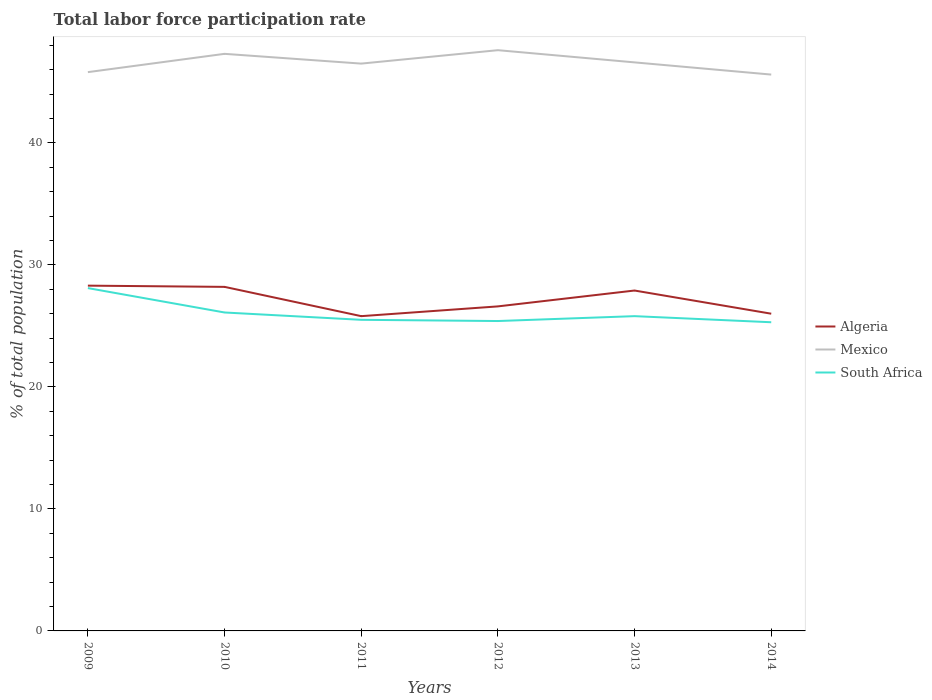Across all years, what is the maximum total labor force participation rate in Mexico?
Ensure brevity in your answer.  45.6. What is the total total labor force participation rate in Algeria in the graph?
Your answer should be very brief. 0.6. Is the total labor force participation rate in Mexico strictly greater than the total labor force participation rate in South Africa over the years?
Offer a very short reply. No. What is the difference between two consecutive major ticks on the Y-axis?
Offer a terse response. 10. Does the graph contain grids?
Your response must be concise. No. Where does the legend appear in the graph?
Offer a very short reply. Center right. How many legend labels are there?
Offer a terse response. 3. How are the legend labels stacked?
Your response must be concise. Vertical. What is the title of the graph?
Provide a succinct answer. Total labor force participation rate. What is the label or title of the Y-axis?
Your response must be concise. % of total population. What is the % of total population of Algeria in 2009?
Offer a very short reply. 28.3. What is the % of total population of Mexico in 2009?
Give a very brief answer. 45.8. What is the % of total population in South Africa in 2009?
Your answer should be compact. 28.1. What is the % of total population of Algeria in 2010?
Offer a terse response. 28.2. What is the % of total population in Mexico in 2010?
Give a very brief answer. 47.3. What is the % of total population of South Africa in 2010?
Provide a succinct answer. 26.1. What is the % of total population of Algeria in 2011?
Provide a succinct answer. 25.8. What is the % of total population of Mexico in 2011?
Keep it short and to the point. 46.5. What is the % of total population of South Africa in 2011?
Offer a terse response. 25.5. What is the % of total population of Algeria in 2012?
Make the answer very short. 26.6. What is the % of total population in Mexico in 2012?
Offer a very short reply. 47.6. What is the % of total population of South Africa in 2012?
Offer a terse response. 25.4. What is the % of total population of Algeria in 2013?
Offer a very short reply. 27.9. What is the % of total population in Mexico in 2013?
Ensure brevity in your answer.  46.6. What is the % of total population of South Africa in 2013?
Offer a terse response. 25.8. What is the % of total population in Algeria in 2014?
Offer a terse response. 26. What is the % of total population of Mexico in 2014?
Give a very brief answer. 45.6. What is the % of total population in South Africa in 2014?
Your answer should be very brief. 25.3. Across all years, what is the maximum % of total population of Algeria?
Your answer should be compact. 28.3. Across all years, what is the maximum % of total population in Mexico?
Provide a succinct answer. 47.6. Across all years, what is the maximum % of total population of South Africa?
Offer a very short reply. 28.1. Across all years, what is the minimum % of total population in Algeria?
Keep it short and to the point. 25.8. Across all years, what is the minimum % of total population of Mexico?
Your answer should be very brief. 45.6. Across all years, what is the minimum % of total population in South Africa?
Offer a terse response. 25.3. What is the total % of total population of Algeria in the graph?
Offer a very short reply. 162.8. What is the total % of total population in Mexico in the graph?
Make the answer very short. 279.4. What is the total % of total population in South Africa in the graph?
Give a very brief answer. 156.2. What is the difference between the % of total population in Algeria in 2009 and that in 2011?
Your answer should be compact. 2.5. What is the difference between the % of total population in South Africa in 2009 and that in 2011?
Offer a very short reply. 2.6. What is the difference between the % of total population in Algeria in 2009 and that in 2012?
Offer a very short reply. 1.7. What is the difference between the % of total population in Mexico in 2009 and that in 2012?
Keep it short and to the point. -1.8. What is the difference between the % of total population in Mexico in 2009 and that in 2013?
Make the answer very short. -0.8. What is the difference between the % of total population of Mexico in 2009 and that in 2014?
Make the answer very short. 0.2. What is the difference between the % of total population of South Africa in 2009 and that in 2014?
Ensure brevity in your answer.  2.8. What is the difference between the % of total population in South Africa in 2010 and that in 2011?
Ensure brevity in your answer.  0.6. What is the difference between the % of total population of South Africa in 2010 and that in 2012?
Offer a terse response. 0.7. What is the difference between the % of total population in Algeria in 2010 and that in 2014?
Offer a terse response. 2.2. What is the difference between the % of total population of Mexico in 2010 and that in 2014?
Offer a very short reply. 1.7. What is the difference between the % of total population in Algeria in 2011 and that in 2012?
Ensure brevity in your answer.  -0.8. What is the difference between the % of total population of Mexico in 2011 and that in 2012?
Provide a succinct answer. -1.1. What is the difference between the % of total population of South Africa in 2011 and that in 2012?
Your response must be concise. 0.1. What is the difference between the % of total population of Algeria in 2011 and that in 2013?
Provide a short and direct response. -2.1. What is the difference between the % of total population in Mexico in 2011 and that in 2013?
Give a very brief answer. -0.1. What is the difference between the % of total population of South Africa in 2011 and that in 2013?
Your answer should be compact. -0.3. What is the difference between the % of total population in Algeria in 2011 and that in 2014?
Your answer should be compact. -0.2. What is the difference between the % of total population in South Africa in 2011 and that in 2014?
Offer a very short reply. 0.2. What is the difference between the % of total population of South Africa in 2012 and that in 2013?
Your response must be concise. -0.4. What is the difference between the % of total population of Algeria in 2012 and that in 2014?
Your response must be concise. 0.6. What is the difference between the % of total population in South Africa in 2012 and that in 2014?
Your answer should be very brief. 0.1. What is the difference between the % of total population in Algeria in 2013 and that in 2014?
Ensure brevity in your answer.  1.9. What is the difference between the % of total population in Mexico in 2013 and that in 2014?
Give a very brief answer. 1. What is the difference between the % of total population of South Africa in 2013 and that in 2014?
Ensure brevity in your answer.  0.5. What is the difference between the % of total population in Algeria in 2009 and the % of total population in Mexico in 2010?
Provide a short and direct response. -19. What is the difference between the % of total population in Mexico in 2009 and the % of total population in South Africa in 2010?
Offer a very short reply. 19.7. What is the difference between the % of total population in Algeria in 2009 and the % of total population in Mexico in 2011?
Keep it short and to the point. -18.2. What is the difference between the % of total population of Algeria in 2009 and the % of total population of South Africa in 2011?
Your response must be concise. 2.8. What is the difference between the % of total population in Mexico in 2009 and the % of total population in South Africa in 2011?
Your response must be concise. 20.3. What is the difference between the % of total population in Algeria in 2009 and the % of total population in Mexico in 2012?
Your answer should be compact. -19.3. What is the difference between the % of total population of Mexico in 2009 and the % of total population of South Africa in 2012?
Provide a succinct answer. 20.4. What is the difference between the % of total population in Algeria in 2009 and the % of total population in Mexico in 2013?
Ensure brevity in your answer.  -18.3. What is the difference between the % of total population of Mexico in 2009 and the % of total population of South Africa in 2013?
Provide a succinct answer. 20. What is the difference between the % of total population in Algeria in 2009 and the % of total population in Mexico in 2014?
Provide a succinct answer. -17.3. What is the difference between the % of total population of Algeria in 2009 and the % of total population of South Africa in 2014?
Keep it short and to the point. 3. What is the difference between the % of total population of Mexico in 2009 and the % of total population of South Africa in 2014?
Ensure brevity in your answer.  20.5. What is the difference between the % of total population in Algeria in 2010 and the % of total population in Mexico in 2011?
Provide a short and direct response. -18.3. What is the difference between the % of total population of Algeria in 2010 and the % of total population of South Africa in 2011?
Your answer should be very brief. 2.7. What is the difference between the % of total population of Mexico in 2010 and the % of total population of South Africa in 2011?
Offer a very short reply. 21.8. What is the difference between the % of total population of Algeria in 2010 and the % of total population of Mexico in 2012?
Offer a very short reply. -19.4. What is the difference between the % of total population of Algeria in 2010 and the % of total population of South Africa in 2012?
Provide a short and direct response. 2.8. What is the difference between the % of total population of Mexico in 2010 and the % of total population of South Africa in 2012?
Ensure brevity in your answer.  21.9. What is the difference between the % of total population in Algeria in 2010 and the % of total population in Mexico in 2013?
Keep it short and to the point. -18.4. What is the difference between the % of total population of Algeria in 2010 and the % of total population of South Africa in 2013?
Your response must be concise. 2.4. What is the difference between the % of total population in Mexico in 2010 and the % of total population in South Africa in 2013?
Offer a very short reply. 21.5. What is the difference between the % of total population in Algeria in 2010 and the % of total population in Mexico in 2014?
Make the answer very short. -17.4. What is the difference between the % of total population of Algeria in 2011 and the % of total population of Mexico in 2012?
Provide a succinct answer. -21.8. What is the difference between the % of total population in Algeria in 2011 and the % of total population in South Africa in 2012?
Your answer should be very brief. 0.4. What is the difference between the % of total population of Mexico in 2011 and the % of total population of South Africa in 2012?
Offer a very short reply. 21.1. What is the difference between the % of total population of Algeria in 2011 and the % of total population of Mexico in 2013?
Keep it short and to the point. -20.8. What is the difference between the % of total population in Mexico in 2011 and the % of total population in South Africa in 2013?
Provide a short and direct response. 20.7. What is the difference between the % of total population of Algeria in 2011 and the % of total population of Mexico in 2014?
Ensure brevity in your answer.  -19.8. What is the difference between the % of total population in Mexico in 2011 and the % of total population in South Africa in 2014?
Offer a terse response. 21.2. What is the difference between the % of total population of Algeria in 2012 and the % of total population of Mexico in 2013?
Give a very brief answer. -20. What is the difference between the % of total population of Mexico in 2012 and the % of total population of South Africa in 2013?
Provide a succinct answer. 21.8. What is the difference between the % of total population in Algeria in 2012 and the % of total population in Mexico in 2014?
Your answer should be compact. -19. What is the difference between the % of total population of Algeria in 2012 and the % of total population of South Africa in 2014?
Give a very brief answer. 1.3. What is the difference between the % of total population of Mexico in 2012 and the % of total population of South Africa in 2014?
Your answer should be very brief. 22.3. What is the difference between the % of total population in Algeria in 2013 and the % of total population in Mexico in 2014?
Offer a very short reply. -17.7. What is the difference between the % of total population in Mexico in 2013 and the % of total population in South Africa in 2014?
Your answer should be compact. 21.3. What is the average % of total population in Algeria per year?
Keep it short and to the point. 27.13. What is the average % of total population of Mexico per year?
Give a very brief answer. 46.57. What is the average % of total population in South Africa per year?
Make the answer very short. 26.03. In the year 2009, what is the difference between the % of total population of Algeria and % of total population of Mexico?
Ensure brevity in your answer.  -17.5. In the year 2009, what is the difference between the % of total population in Mexico and % of total population in South Africa?
Your answer should be compact. 17.7. In the year 2010, what is the difference between the % of total population of Algeria and % of total population of Mexico?
Offer a terse response. -19.1. In the year 2010, what is the difference between the % of total population in Mexico and % of total population in South Africa?
Ensure brevity in your answer.  21.2. In the year 2011, what is the difference between the % of total population of Algeria and % of total population of Mexico?
Provide a short and direct response. -20.7. In the year 2011, what is the difference between the % of total population in Algeria and % of total population in South Africa?
Make the answer very short. 0.3. In the year 2011, what is the difference between the % of total population in Mexico and % of total population in South Africa?
Offer a terse response. 21. In the year 2012, what is the difference between the % of total population in Algeria and % of total population in Mexico?
Keep it short and to the point. -21. In the year 2013, what is the difference between the % of total population of Algeria and % of total population of Mexico?
Offer a very short reply. -18.7. In the year 2013, what is the difference between the % of total population in Mexico and % of total population in South Africa?
Your answer should be compact. 20.8. In the year 2014, what is the difference between the % of total population in Algeria and % of total population in Mexico?
Your answer should be compact. -19.6. In the year 2014, what is the difference between the % of total population of Mexico and % of total population of South Africa?
Your answer should be very brief. 20.3. What is the ratio of the % of total population in Mexico in 2009 to that in 2010?
Your answer should be compact. 0.97. What is the ratio of the % of total population in South Africa in 2009 to that in 2010?
Give a very brief answer. 1.08. What is the ratio of the % of total population in Algeria in 2009 to that in 2011?
Your response must be concise. 1.1. What is the ratio of the % of total population in Mexico in 2009 to that in 2011?
Ensure brevity in your answer.  0.98. What is the ratio of the % of total population of South Africa in 2009 to that in 2011?
Give a very brief answer. 1.1. What is the ratio of the % of total population of Algeria in 2009 to that in 2012?
Offer a terse response. 1.06. What is the ratio of the % of total population in Mexico in 2009 to that in 2012?
Keep it short and to the point. 0.96. What is the ratio of the % of total population of South Africa in 2009 to that in 2012?
Your answer should be very brief. 1.11. What is the ratio of the % of total population in Algeria in 2009 to that in 2013?
Give a very brief answer. 1.01. What is the ratio of the % of total population in Mexico in 2009 to that in 2013?
Offer a terse response. 0.98. What is the ratio of the % of total population of South Africa in 2009 to that in 2013?
Your answer should be compact. 1.09. What is the ratio of the % of total population of Algeria in 2009 to that in 2014?
Make the answer very short. 1.09. What is the ratio of the % of total population of Mexico in 2009 to that in 2014?
Offer a terse response. 1. What is the ratio of the % of total population in South Africa in 2009 to that in 2014?
Make the answer very short. 1.11. What is the ratio of the % of total population in Algeria in 2010 to that in 2011?
Offer a very short reply. 1.09. What is the ratio of the % of total population in Mexico in 2010 to that in 2011?
Your answer should be compact. 1.02. What is the ratio of the % of total population in South Africa in 2010 to that in 2011?
Ensure brevity in your answer.  1.02. What is the ratio of the % of total population in Algeria in 2010 to that in 2012?
Make the answer very short. 1.06. What is the ratio of the % of total population of Mexico in 2010 to that in 2012?
Your response must be concise. 0.99. What is the ratio of the % of total population in South Africa in 2010 to that in 2012?
Ensure brevity in your answer.  1.03. What is the ratio of the % of total population in Algeria in 2010 to that in 2013?
Make the answer very short. 1.01. What is the ratio of the % of total population in South Africa in 2010 to that in 2013?
Offer a terse response. 1.01. What is the ratio of the % of total population in Algeria in 2010 to that in 2014?
Make the answer very short. 1.08. What is the ratio of the % of total population in Mexico in 2010 to that in 2014?
Keep it short and to the point. 1.04. What is the ratio of the % of total population of South Africa in 2010 to that in 2014?
Offer a very short reply. 1.03. What is the ratio of the % of total population of Algeria in 2011 to that in 2012?
Offer a terse response. 0.97. What is the ratio of the % of total population of Mexico in 2011 to that in 2012?
Provide a succinct answer. 0.98. What is the ratio of the % of total population in Algeria in 2011 to that in 2013?
Your answer should be very brief. 0.92. What is the ratio of the % of total population of Mexico in 2011 to that in 2013?
Offer a very short reply. 1. What is the ratio of the % of total population of South Africa in 2011 to that in 2013?
Ensure brevity in your answer.  0.99. What is the ratio of the % of total population in Algeria in 2011 to that in 2014?
Offer a very short reply. 0.99. What is the ratio of the % of total population in Mexico in 2011 to that in 2014?
Provide a succinct answer. 1.02. What is the ratio of the % of total population of South Africa in 2011 to that in 2014?
Make the answer very short. 1.01. What is the ratio of the % of total population of Algeria in 2012 to that in 2013?
Your response must be concise. 0.95. What is the ratio of the % of total population in Mexico in 2012 to that in 2013?
Your answer should be very brief. 1.02. What is the ratio of the % of total population in South Africa in 2012 to that in 2013?
Your answer should be very brief. 0.98. What is the ratio of the % of total population of Algeria in 2012 to that in 2014?
Offer a very short reply. 1.02. What is the ratio of the % of total population of Mexico in 2012 to that in 2014?
Keep it short and to the point. 1.04. What is the ratio of the % of total population in South Africa in 2012 to that in 2014?
Your answer should be compact. 1. What is the ratio of the % of total population in Algeria in 2013 to that in 2014?
Keep it short and to the point. 1.07. What is the ratio of the % of total population in Mexico in 2013 to that in 2014?
Make the answer very short. 1.02. What is the ratio of the % of total population of South Africa in 2013 to that in 2014?
Your answer should be very brief. 1.02. What is the difference between the highest and the second highest % of total population of Algeria?
Give a very brief answer. 0.1. What is the difference between the highest and the second highest % of total population of Mexico?
Provide a short and direct response. 0.3. What is the difference between the highest and the second highest % of total population in South Africa?
Provide a succinct answer. 2. What is the difference between the highest and the lowest % of total population in Algeria?
Ensure brevity in your answer.  2.5. What is the difference between the highest and the lowest % of total population in Mexico?
Your answer should be very brief. 2. What is the difference between the highest and the lowest % of total population in South Africa?
Keep it short and to the point. 2.8. 